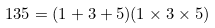Convert formula to latex. <formula><loc_0><loc_0><loc_500><loc_500>1 3 5 = ( 1 + 3 + 5 ) ( 1 \times 3 \times 5 )</formula> 